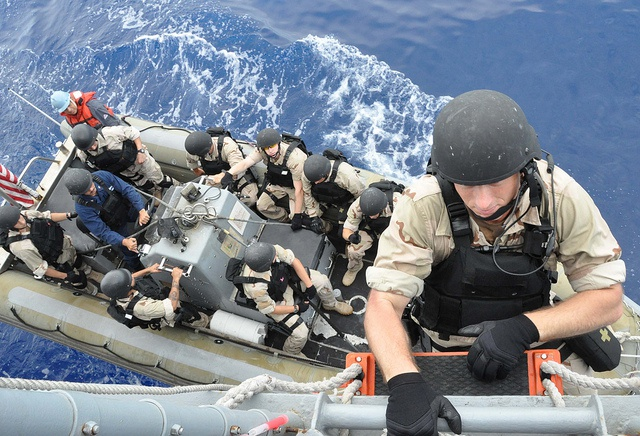Describe the objects in this image and their specific colors. I can see boat in darkgray, black, gray, and lightgray tones, people in darkgray, black, gray, and ivory tones, people in darkgray, black, gray, and lightgray tones, people in darkgray, black, gray, and lightgray tones, and people in darkgray, black, navy, darkblue, and gray tones in this image. 